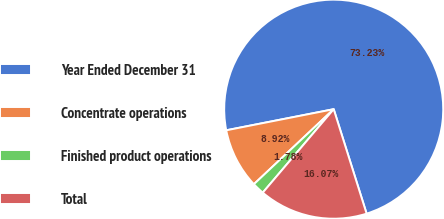<chart> <loc_0><loc_0><loc_500><loc_500><pie_chart><fcel>Year Ended December 31<fcel>Concentrate operations<fcel>Finished product operations<fcel>Total<nl><fcel>73.23%<fcel>8.92%<fcel>1.78%<fcel>16.07%<nl></chart> 